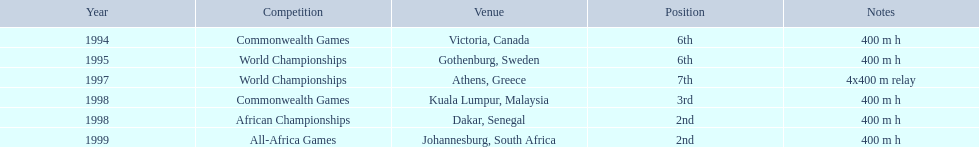Parse the full table in json format. {'header': ['Year', 'Competition', 'Venue', 'Position', 'Notes'], 'rows': [['1994', 'Commonwealth Games', 'Victoria, Canada', '6th', '400 m h'], ['1995', 'World Championships', 'Gothenburg, Sweden', '6th', '400 m h'], ['1997', 'World Championships', 'Athens, Greece', '7th', '4x400 m relay'], ['1998', 'Commonwealth Games', 'Kuala Lumpur, Malaysia', '3rd', '400 m h'], ['1998', 'African Championships', 'Dakar, Senegal', '2nd', '400 m h'], ['1999', 'All-Africa Games', 'Johannesburg, South Africa', '2nd', '400 m h']]} In what years was ken harder a competitor? 1994, 1995, 1997, 1998, 1998, 1999. What was the length of the 1997 relay? 4x400 m relay. 